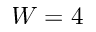Convert formula to latex. <formula><loc_0><loc_0><loc_500><loc_500>W = 4</formula> 